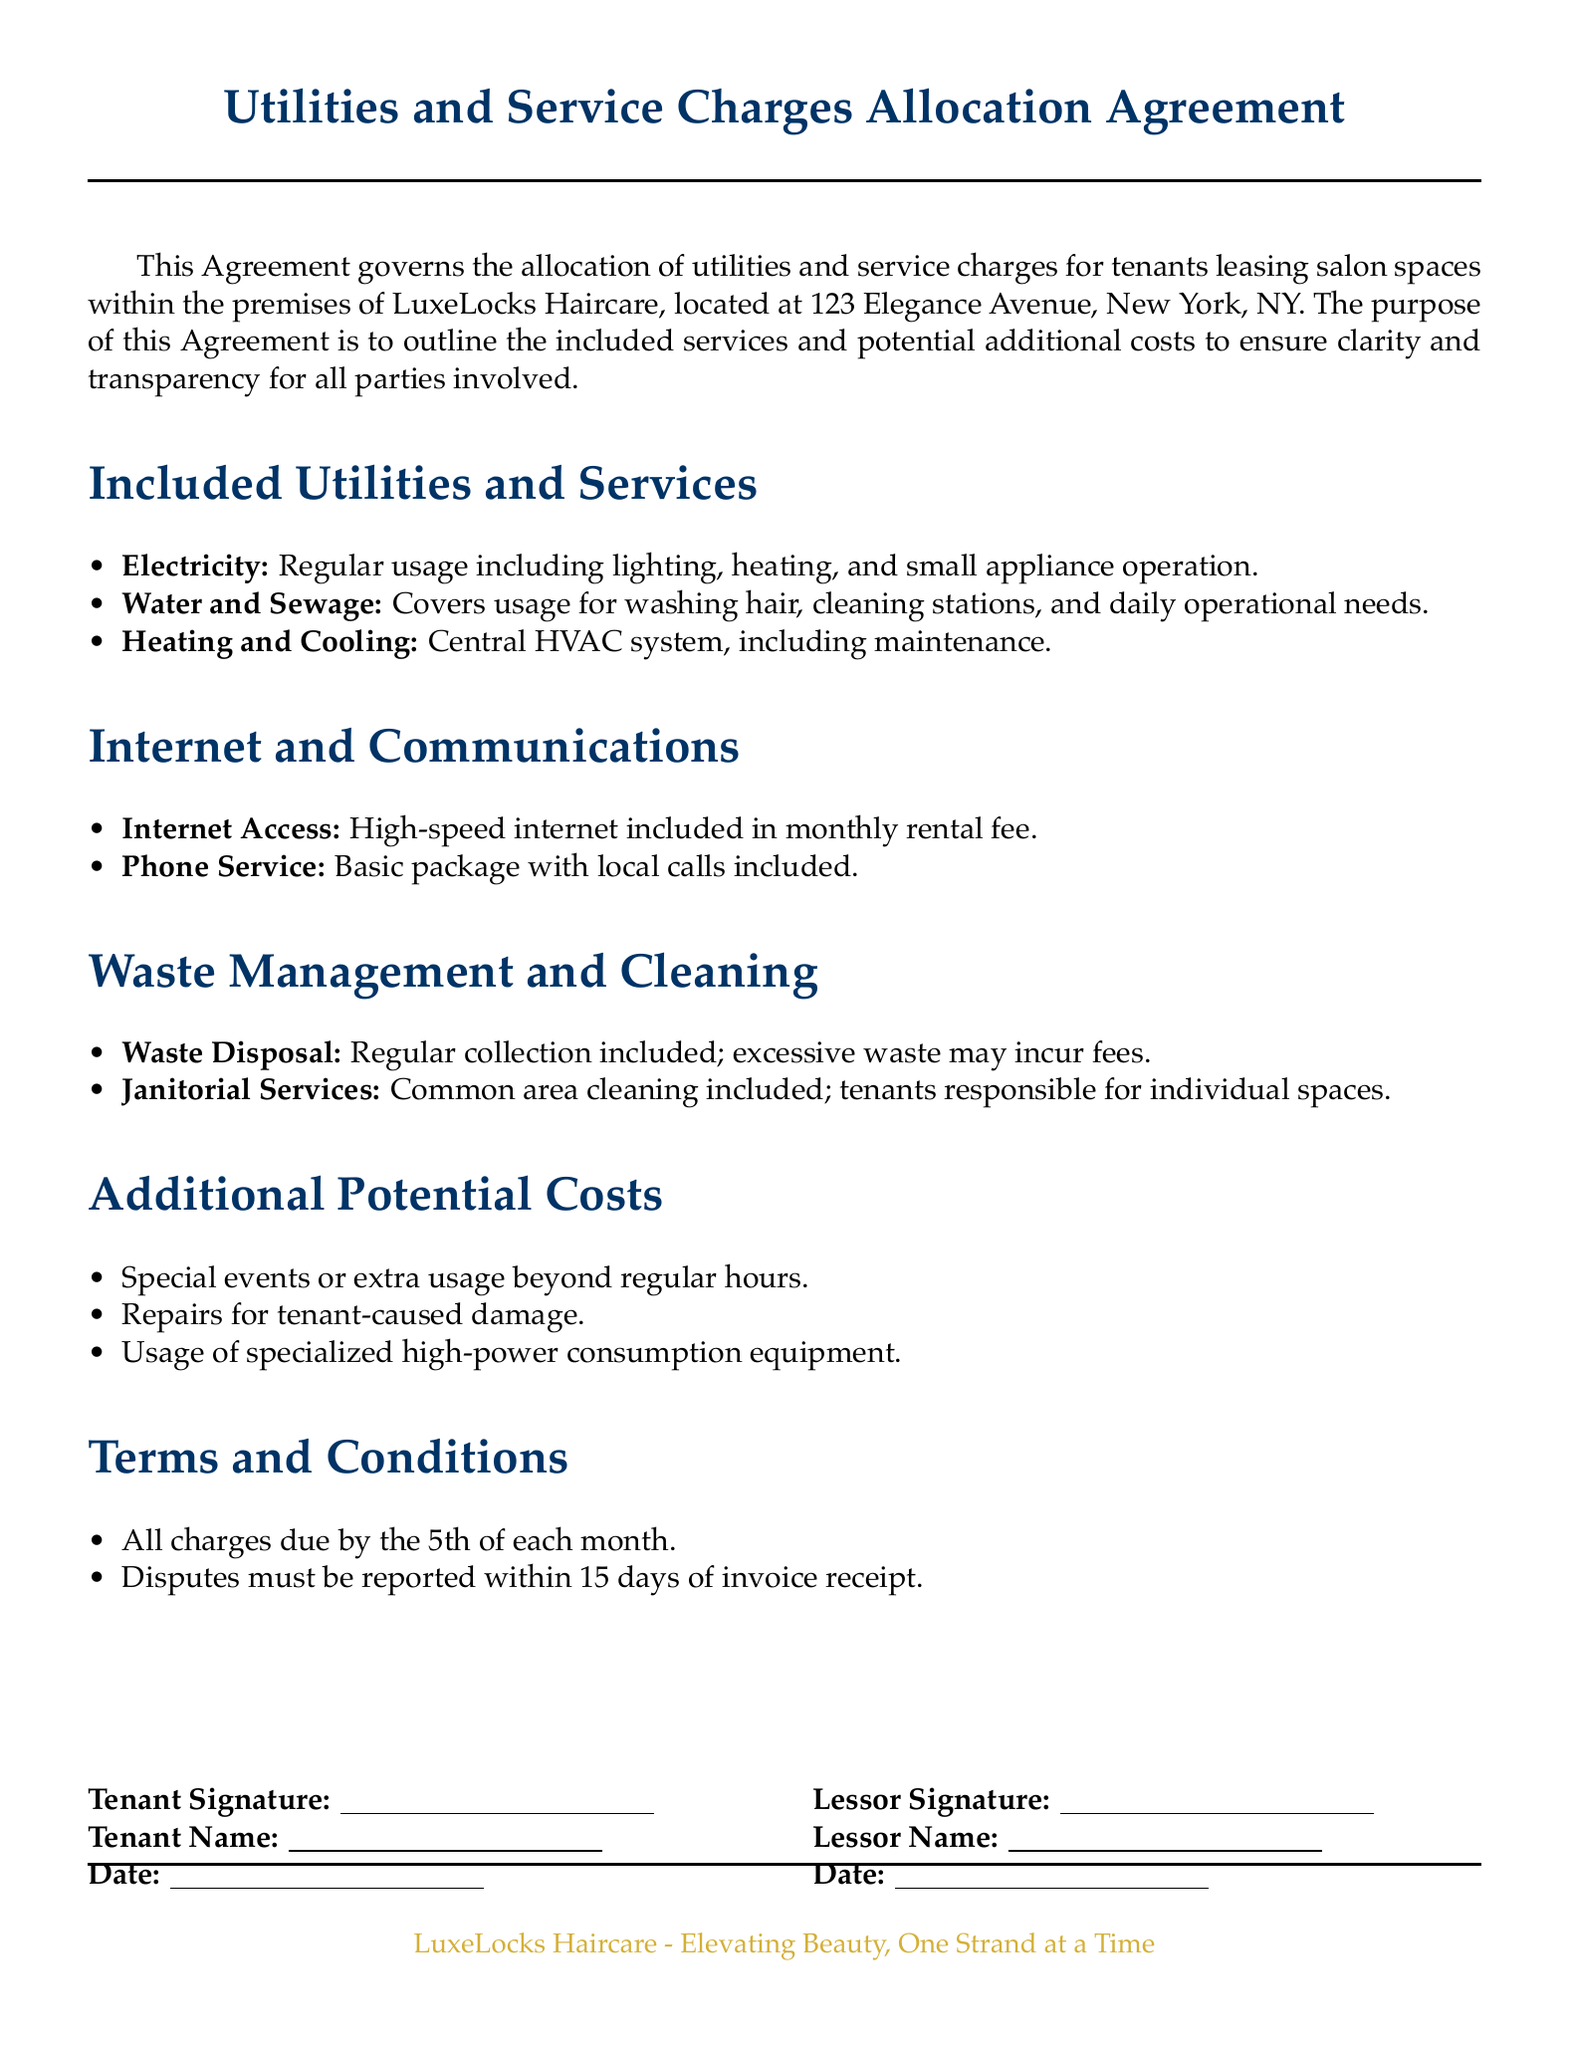What is the address of LuxeLocks Haircare? The address is explicitly stated in the document.
Answer: 123 Elegance Avenue, New York, NY What utilities are included in the Agreement? The Agreement lists several utilities under the included services section.
Answer: Electricity, Water and Sewage, Heating and Cooling What date are all charges due? The document specifies the due date for charges in the terms and conditions section.
Answer: 5th of each month What service is responsible for cleaning common areas? The document outlines the waste management and cleaning services, specifying responsibilities.
Answer: Janitorial Services What is required to report disputes? The document describes a timeline for reporting disputes in the terms and conditions section.
Answer: Within 15 days of invoice receipt What might incur additional fees under waste management? The Agreement details potential costs related to excessive waste within the waste management section.
Answer: Excessive waste What additional potential costs could arise from special events? The document outlines potential costs associated with specific activities in the relevant section.
Answer: Special events or extra usage beyond regular hours Who needs to sign the Agreement? The document indicates there are signature lines for two parties involved in the lease.
Answer: Tenant and Lessor 